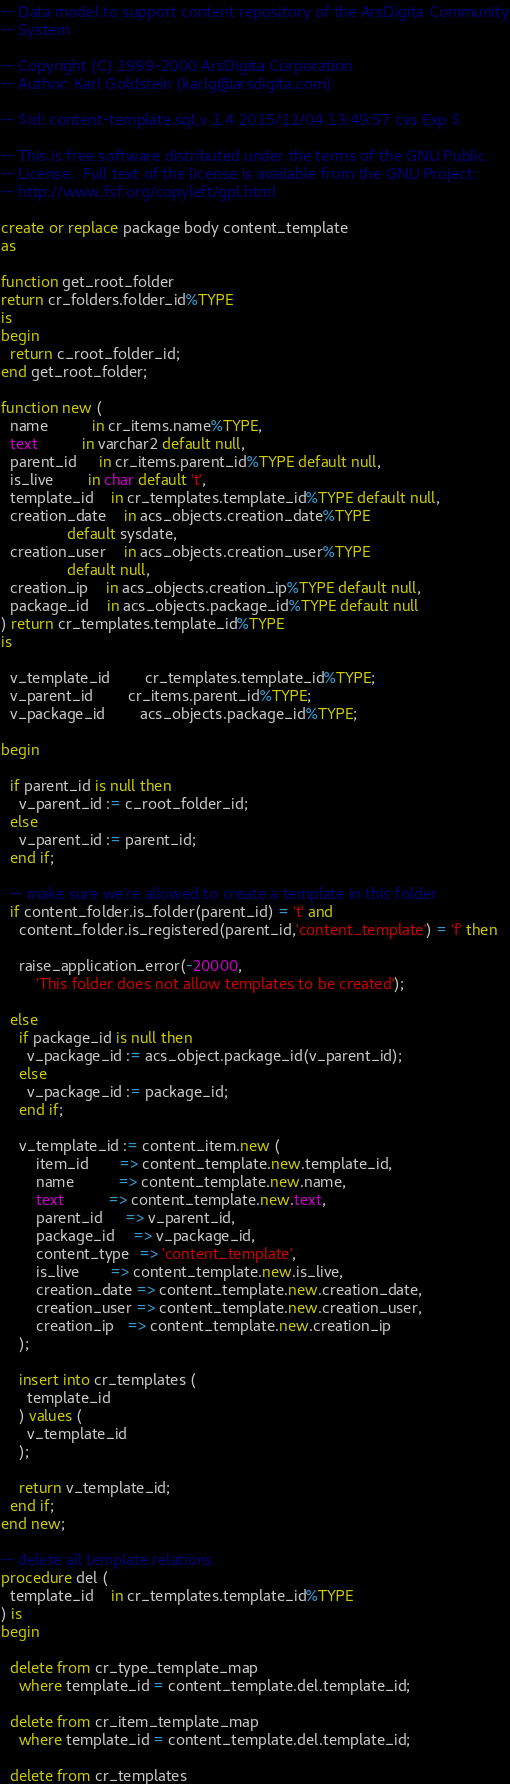Convert code to text. <code><loc_0><loc_0><loc_500><loc_500><_SQL_>-- Data model to support content repository of the ArsDigita Community
-- System

-- Copyright (C) 1999-2000 ArsDigita Corporation
-- Author: Karl Goldstein (karlg@arsdigita.com)

-- $Id: content-template.sql,v 1.4 2015/12/04 13:49:57 cvs Exp $

-- This is free software distributed under the terms of the GNU Public
-- License.  Full text of the license is available from the GNU Project:
-- http://www.fsf.org/copyleft/gpl.html

create or replace package body content_template
as

function get_root_folder
return cr_folders.folder_id%TYPE
is
begin
  return c_root_folder_id;
end get_root_folder;

function new (
  name          in cr_items.name%TYPE,
  text          in varchar2 default null,
  parent_id     in cr_items.parent_id%TYPE default null,
  is_live 		in char default 't',
  template_id	in cr_templates.template_id%TYPE default null,
  creation_date	in acs_objects.creation_date%TYPE
			   default sysdate,
  creation_user	in acs_objects.creation_user%TYPE
			   default null,
  creation_ip	in acs_objects.creation_ip%TYPE default null,
  package_id    in acs_objects.package_id%TYPE default null 
) return cr_templates.template_id%TYPE
is

  v_template_id		cr_templates.template_id%TYPE;
  v_parent_id		cr_items.parent_id%TYPE;
  v_package_id		acs_objects.package_id%TYPE;

begin

  if parent_id is null then
    v_parent_id := c_root_folder_id;
  else
    v_parent_id := parent_id;
  end if;

  -- make sure we're allowed to create a template in this folder
  if content_folder.is_folder(parent_id) = 't' and
    content_folder.is_registered(parent_id,'content_template') = 'f' then

    raise_application_error(-20000, 
        'This folder does not allow templates to be created');

  else
    if package_id is null then
      v_package_id := acs_object.package_id(v_parent_id);
    else
      v_package_id := package_id;
    end if;

    v_template_id := content_item.new (
        item_id       => content_template.new.template_id,
        name          => content_template.new.name, 
        text          => content_template.new.text, 
        parent_id     => v_parent_id,
        package_id    => v_package_id,
        content_type  => 'content_template',
        is_live       => content_template.new.is_live, 
        creation_date => content_template.new.creation_date, 
        creation_user => content_template.new.creation_user, 
        creation_ip   => content_template.new.creation_ip
    );

    insert into cr_templates ( 
      template_id 
    ) values (
      v_template_id
    );

    return v_template_id;
  end if;
end new;                 

-- delete all template relations
procedure del (
  template_id	in cr_templates.template_id%TYPE
) is
begin

  delete from cr_type_template_map
    where template_id = content_template.del.template_id;

  delete from cr_item_template_map
    where template_id = content_template.del.template_id;
 
  delete from cr_templates</code> 